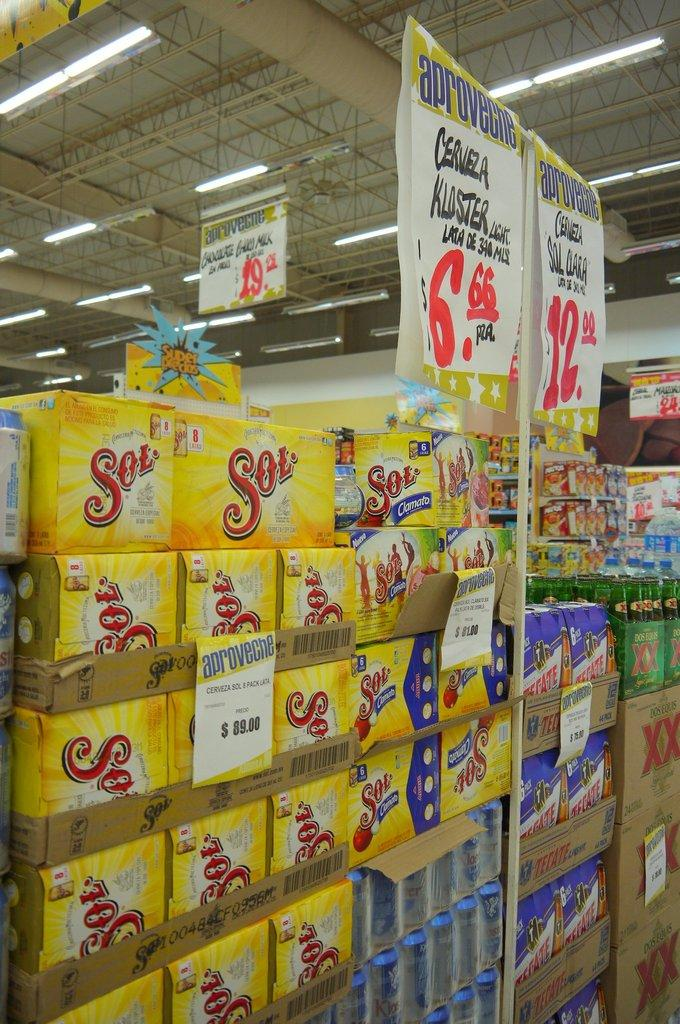<image>
Create a compact narrative representing the image presented. Several yellow boxes of Sol are stacked on top of each other. 